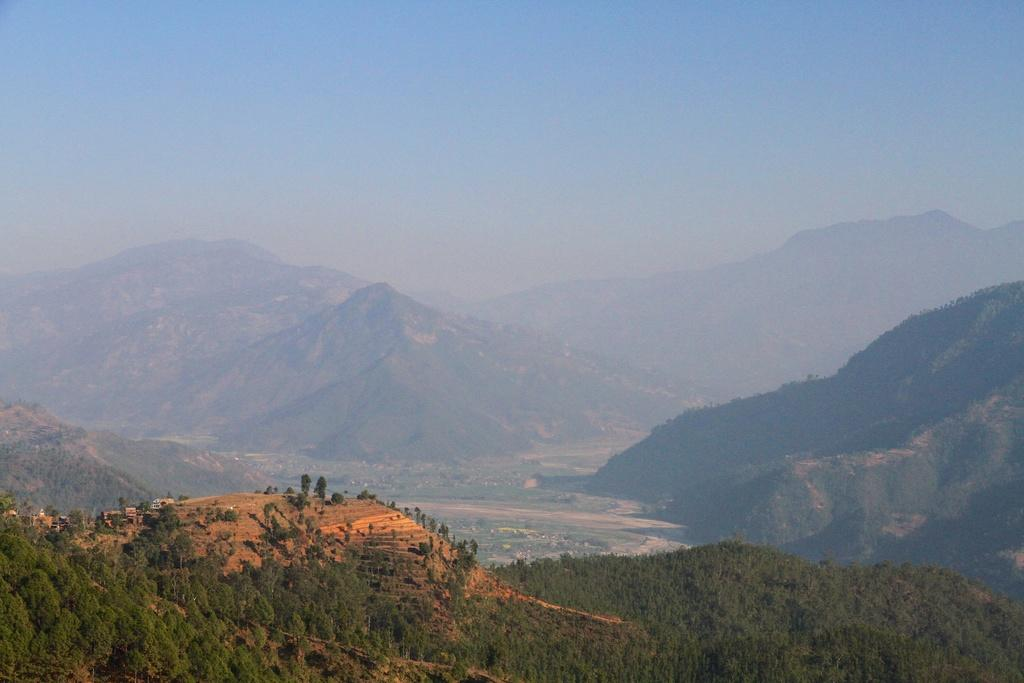What type of natural landform can be seen in the image? There are mountains in the image. What type of vegetation is present in the image? There are trees in the image. What part of the natural environment is visible in the image? The ground and the sky are visible in the image. What type of floor can be seen in the image? There is no floor present in the image, as it features mountains and trees in an outdoor setting. 